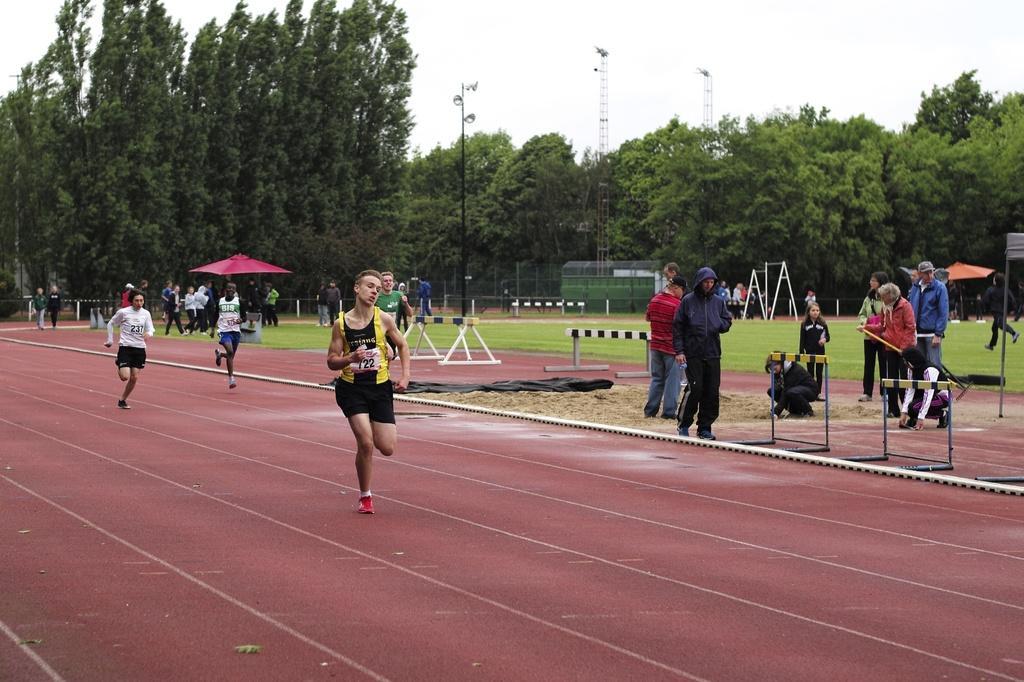Please provide a concise description of this image. In this image I can see l people are running some are standing , and I can see the garden in the middle there are many trees, background is the sky. 